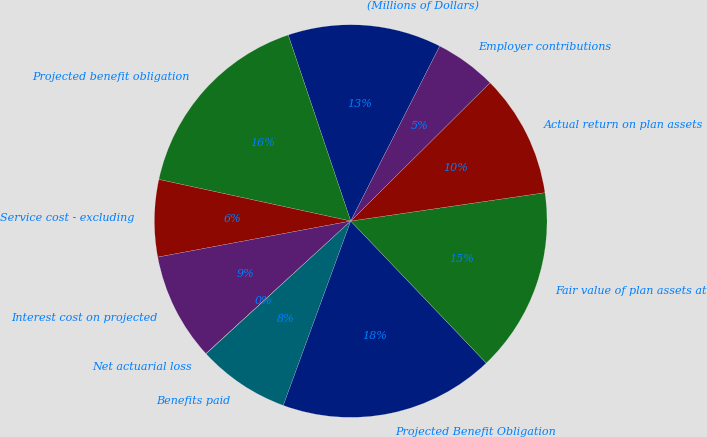Convert chart to OTSL. <chart><loc_0><loc_0><loc_500><loc_500><pie_chart><fcel>(Millions of Dollars)<fcel>Projected benefit obligation<fcel>Service cost - excluding<fcel>Interest cost on projected<fcel>Net actuarial loss<fcel>Benefits paid<fcel>Projected Benefit Obligation<fcel>Fair value of plan assets at<fcel>Actual return on plan assets<fcel>Employer contributions<nl><fcel>12.65%<fcel>16.44%<fcel>6.34%<fcel>8.86%<fcel>0.02%<fcel>7.6%<fcel>17.71%<fcel>15.18%<fcel>10.13%<fcel>5.07%<nl></chart> 